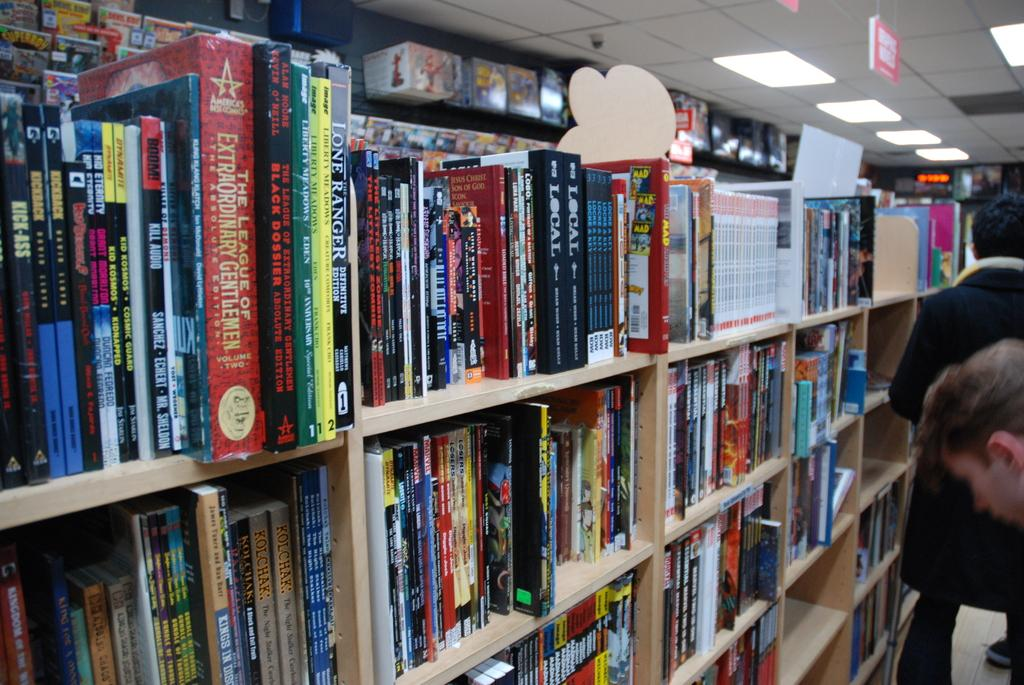Provide a one-sentence caption for the provided image. A book called The Black Dossier is on a shelf in a book store. 